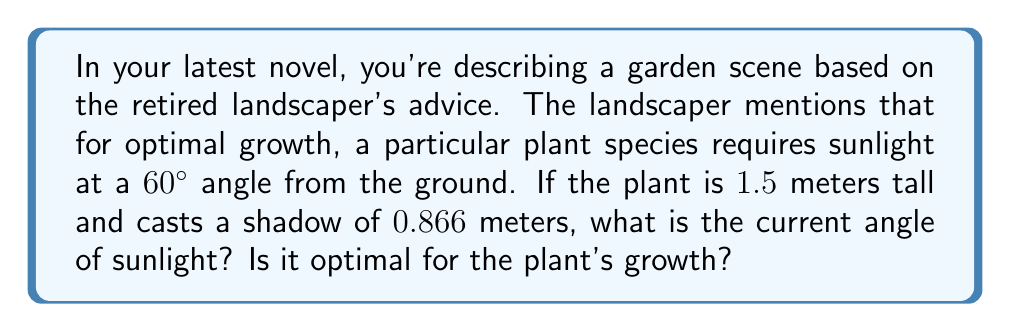Show me your answer to this math problem. To solve this problem, we can use trigonometry, specifically the tangent function. Let's break it down step-by-step:

1) In a right triangle formed by the plant and its shadow, we have:
   - The opposite side (plant height) = 1.5 meters
   - The adjacent side (shadow length) = 0.866 meters
   - The angle we're looking for is between the ground and the sun's rays

2) The tangent of an angle in a right triangle is defined as:

   $$\tan(\theta) = \frac{\text{opposite}}{\text{adjacent}}$$

3) Substituting our values:

   $$\tan(\theta) = \frac{1.5}{0.866}$$

4) To find the angle, we need to use the inverse tangent (arctan or $\tan^{-1}$):

   $$\theta = \tan^{-1}\left(\frac{1.5}{0.866}\right)$$

5) Using a calculator or computer:

   $$\theta \approx 60.0°$$

6) Comparing to the optimal angle:
   The current angle (60.0°) is essentially the same as the optimal angle (60°) mentioned by the landscaper.

[asy]
import geometry;

size(200);
pair A = (0,0), B = (8.66,0), C = (0,15);
draw(A--B--C--A);
draw(A--C,dashed);
label("1.5m",A--C,W);
label("0.866m",A--B,S);
label("60°",A,NE);
[/asy]
Answer: The current angle of sunlight is approximately 60.0°, which is optimal for the plant's growth as it matches the 60° angle advised by the landscaper. 